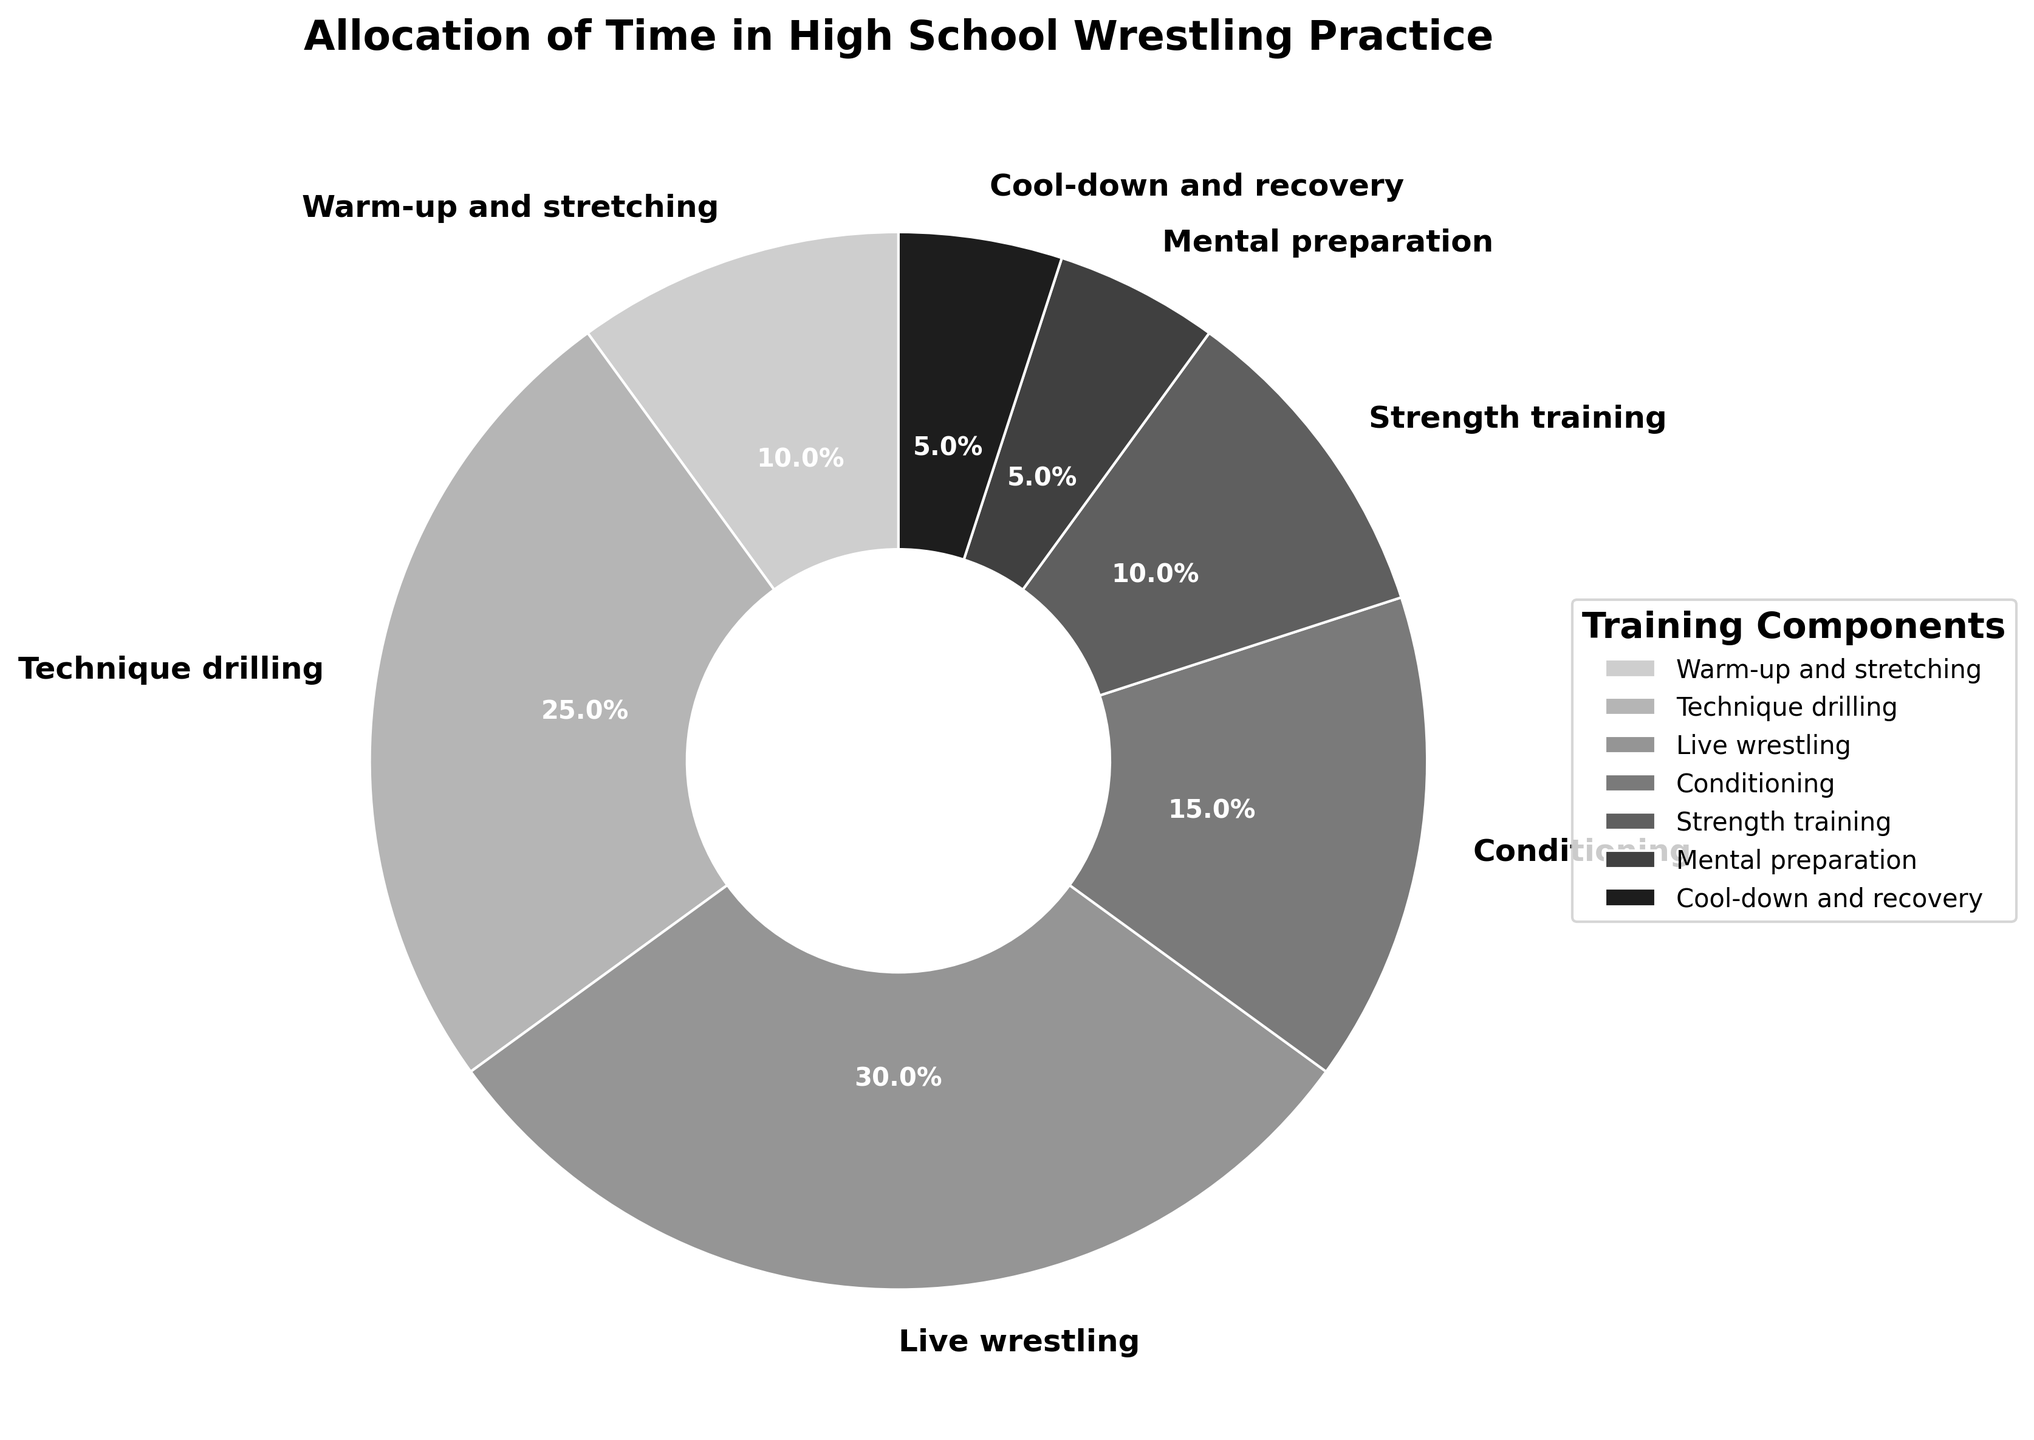Which training component uses the largest percentage of time? By observing the pie chart, we can see the largest wedge, marked "Live wrestling," occupies 30% of the total time.
Answer: Live wrestling What is the combined percentage of time spent on conditioning and strength training? The chart shows that conditioning takes up 15% and strength training takes up 10%. Adding these together, 15% + 10% = 25%.
Answer: 25% Which components share the same percentage of practice time? From the figure, we see that both "Warm-up and stretching" and "Strength training" are marked as occupying 10% each.
Answer: Warm-up and stretching, Strength training How much more time is spent on live wrestling compared to mental preparation? The pie chart indicates that 30% is allocated to live wrestling and 5% to mental preparation. The difference is 30% - 5% = 25%.
Answer: 25% Are there more practice components above or below 10% time allocation? Examining the chart, two components (Live wrestling and Technique drilling) exceed 10%, while four components (Warm-up and stretching, Mental preparation, Cool-down and recovery, and Strength training) are at or below 10%. There are more components below 10%.
Answer: Below 10% What percentage of practice time is spent on non-physical preparation (mental preparation and cool-down and recovery)? The chart shows mental preparation at 5% and cool-down and recovery also at 5%. Adding these together, 5% + 5% = 10%.
Answer: 10% Which training component occupies the smallest portion of the practice time? By looking at the smallest wedge on the chart, both "Mental preparation" and "Cool-down and recovery" share the smallest portion at 5% each.
Answer: Mental preparation, Cool-down and recovery 